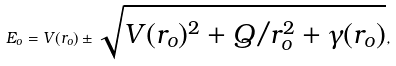Convert formula to latex. <formula><loc_0><loc_0><loc_500><loc_500>E _ { o } = V ( r _ { o } ) \pm \sqrt { V ( r _ { o } ) ^ { 2 } + Q / r _ { o } ^ { 2 } + \gamma ( r _ { o } ) } ,</formula> 